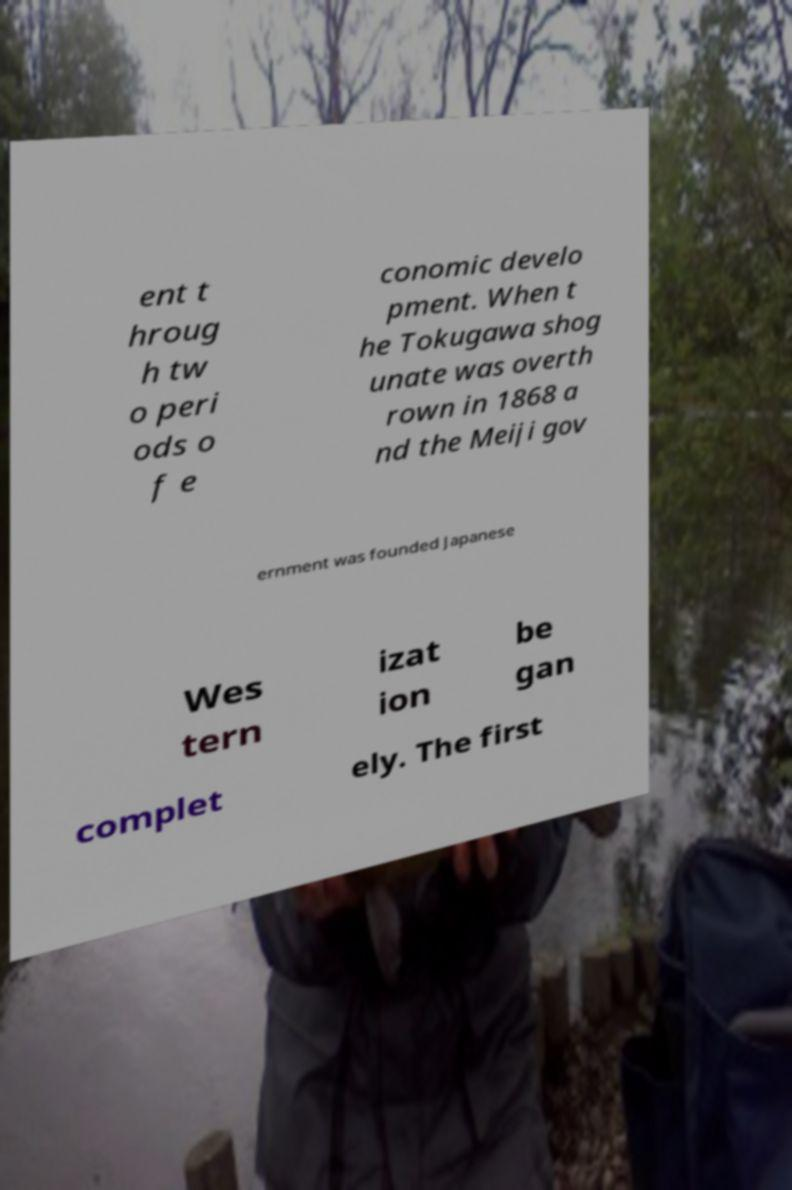Please read and relay the text visible in this image. What does it say? ent t hroug h tw o peri ods o f e conomic develo pment. When t he Tokugawa shog unate was overth rown in 1868 a nd the Meiji gov ernment was founded Japanese Wes tern izat ion be gan complet ely. The first 